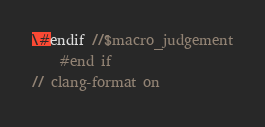Convert code to text. <code><loc_0><loc_0><loc_500><loc_500><_C_>\#endif //$macro_judgement
    #end if
// clang-format on
</code> 